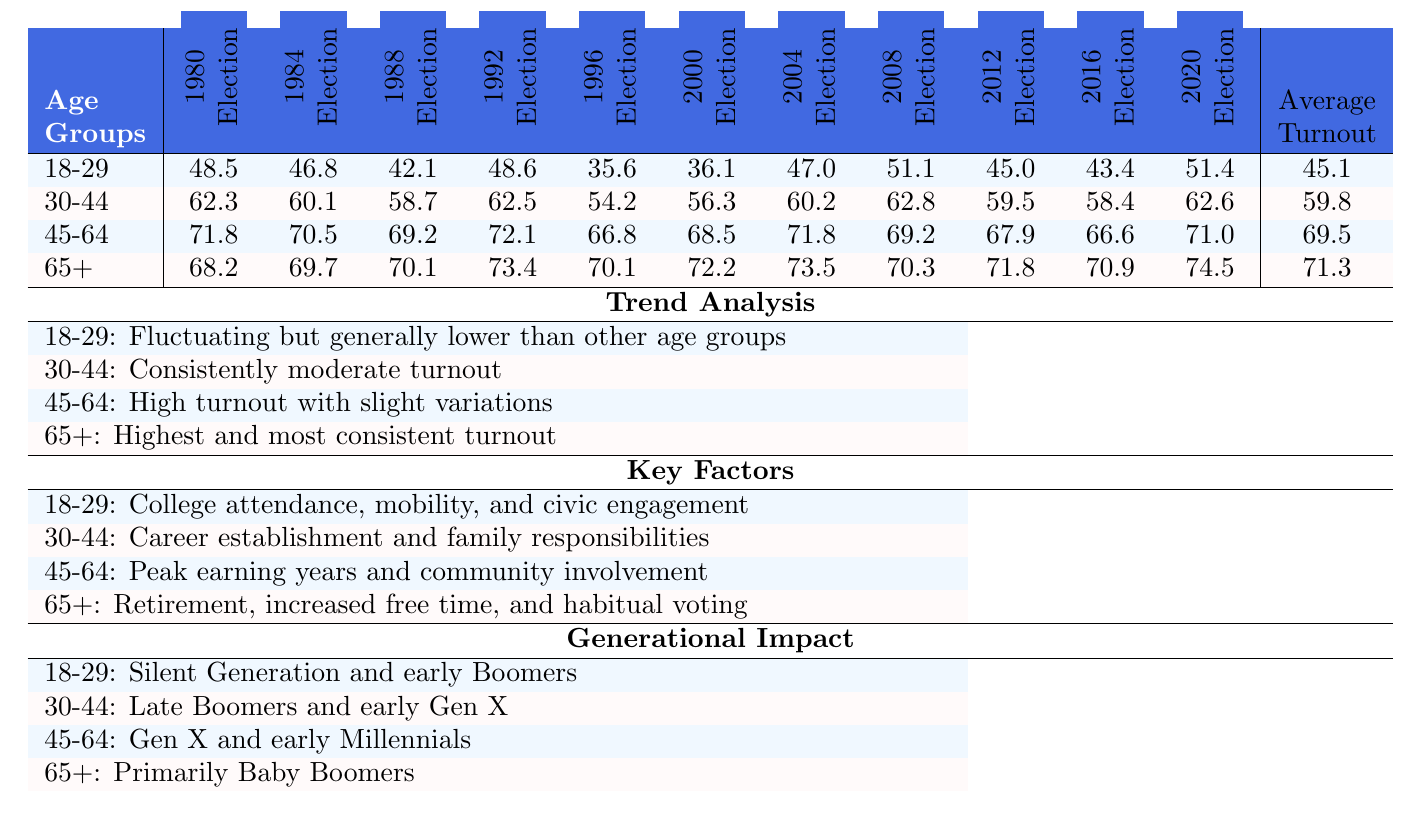What was the voter turnout percentage for the 18-29 age group in the 2008 election? From the table, we look at the column for the 2008 election under the 18-29 age group, which shows a turnout of 51.1%.
Answer: 51.1 Which age group had the highest average voter turnout percentage? By examining the "Average Turnout" row in the table, we see that the 65+ age group has the highest average turnout at 71.3%.
Answer: 65+ What is the difference in voter turnout between the 30-44 age group in the 1992 and 2008 elections? We find the turnout for the 30-44 age group in the 1992 election (62.5%) and in the 2008 election (62.8%). The difference is 62.8 - 62.5 = 0.3%.
Answer: 0.3 Did the voter turnout for the 18-29 age group increase in the 2020 election compared to the 2016 election? The turnout for the 18-29 age group in 2016 was 43.4% and in 2020 it was 51.4%. Since 51.4 is greater than 43.4, the turnout did indeed increase.
Answer: Yes What trend can we observe for the turnout of the 45-64 age group from 1980 to 2020? Looking at the values for this age group across the elections, we see fluctuations with a general trend of high turnout around the 71% mark in recent elections, indicating stability and consistency.
Answer: High and consistent turnout What were the key factors influencing the voter turnout for the 30-44 age group? The table indicates that for the 30-44 age group, key factors include career establishment and family responsibilities, which help explain their consistent yet moderate turnout.
Answer: Career establishment and family responsibilities Compare the average turnout of the 18-29 and 45-64 age groups. What do you notice? The average turnout for the 18-29 age group is 45.1% while for the 45-64 age group it is 69.5%. This indicates a significant difference, with the older age group having a much higher average turnout.
Answer: The 45-64 age group has much higher turnout Which age group had the lowest turnout percentage in the 1996 election? By checking the turnout statistics for each age group in the 1996 election, we find that the 18-29 age group had the lowest turnout at 35.6%.
Answer: 18-29 Is it true that the youth (18-29 age group) generally has higher turnout than the older demographic (65+ age group)? The data shows that the 18-29 age group typically has lower voter turnout percentages compared to the 65+ age group, contradicting the statement.
Answer: No What was the overall trend in voter turnout percentages for the 65+ age group from 1980 to 2020? Analyzing the column for the 65+ age group reveals that their turnout percentages show a slight increase with values mostly above 70%, indicating a steady increase over the years.
Answer: Slight increase over the years 